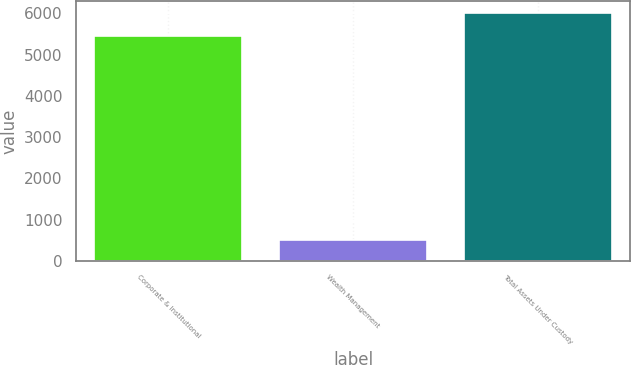Convert chart. <chart><loc_0><loc_0><loc_500><loc_500><bar_chart><fcel>Corporate & Institutional<fcel>Wealth Management<fcel>Total Assets Under Custody<nl><fcel>5453.1<fcel>515.7<fcel>5998.41<nl></chart> 